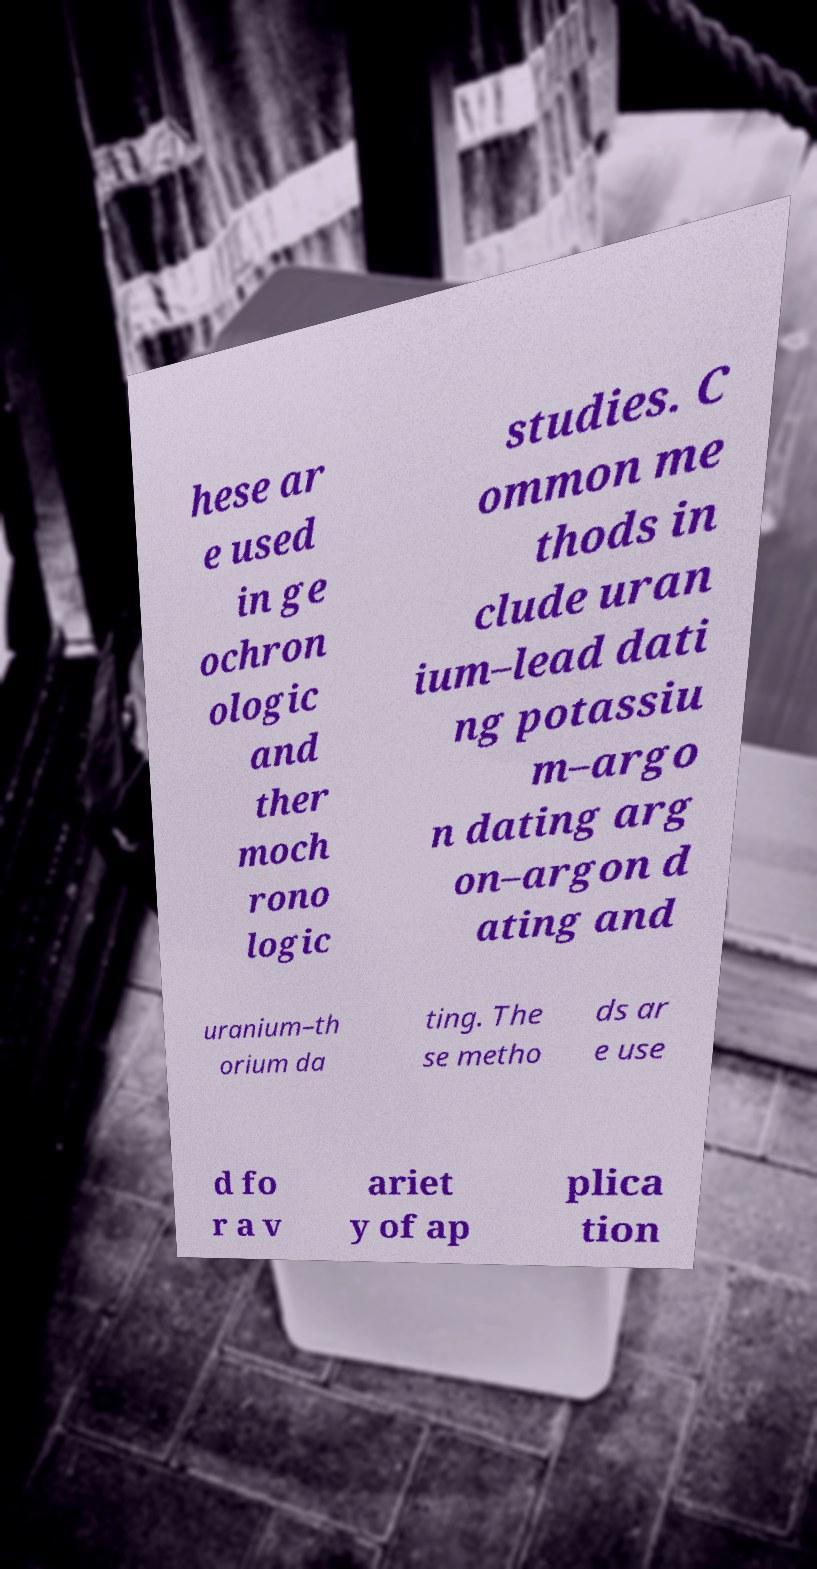What messages or text are displayed in this image? I need them in a readable, typed format. hese ar e used in ge ochron ologic and ther moch rono logic studies. C ommon me thods in clude uran ium–lead dati ng potassiu m–argo n dating arg on–argon d ating and uranium–th orium da ting. The se metho ds ar e use d fo r a v ariet y of ap plica tion 